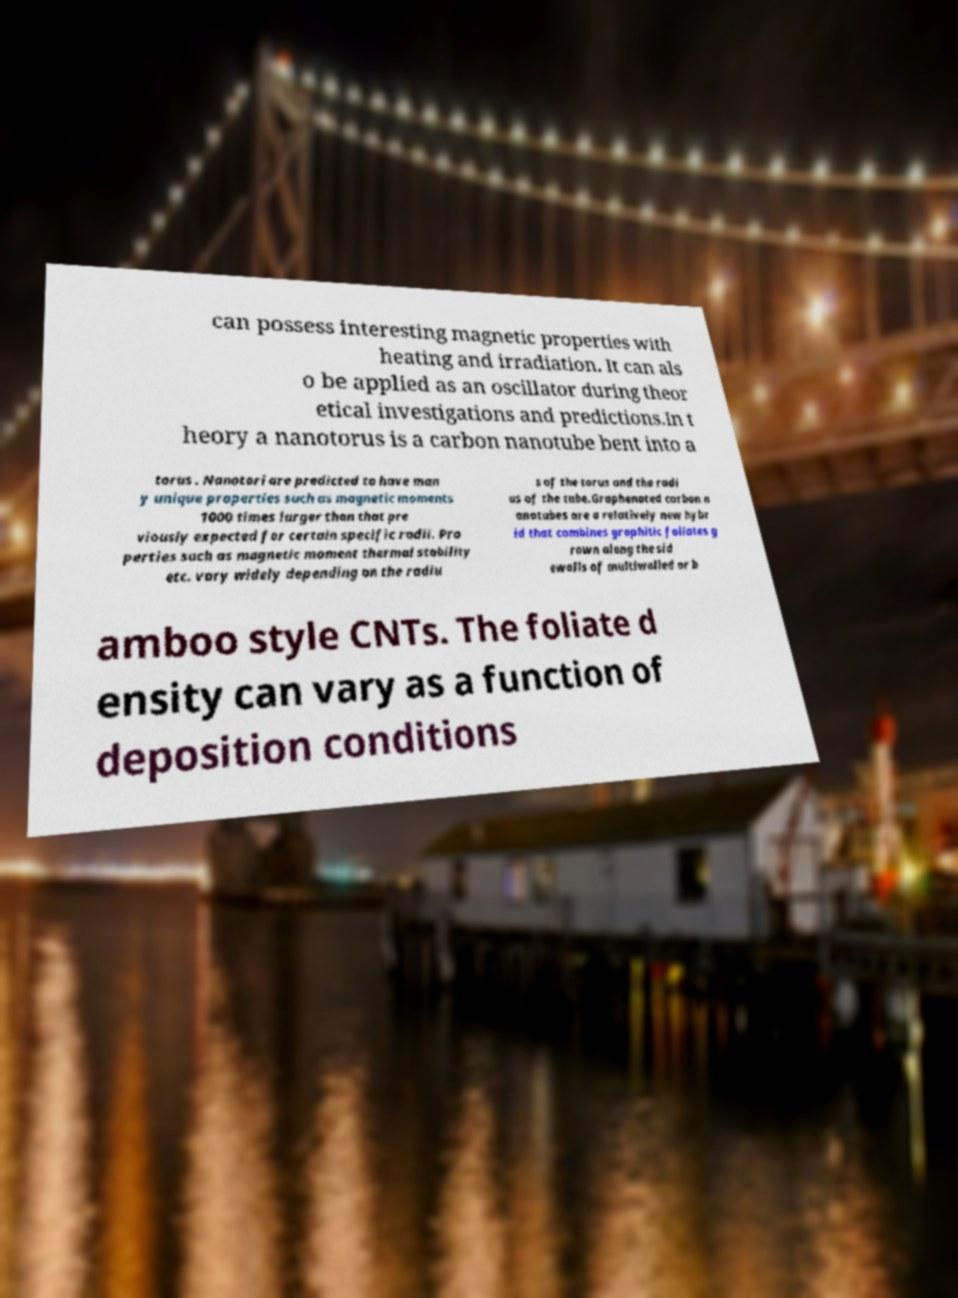What messages or text are displayed in this image? I need them in a readable, typed format. can possess interesting magnetic properties with heating and irradiation. It can als o be applied as an oscillator during theor etical investigations and predictions.In t heory a nanotorus is a carbon nanotube bent into a torus . Nanotori are predicted to have man y unique properties such as magnetic moments 1000 times larger than that pre viously expected for certain specific radii. Pro perties such as magnetic moment thermal stability etc. vary widely depending on the radiu s of the torus and the radi us of the tube.Graphenated carbon n anotubes are a relatively new hybr id that combines graphitic foliates g rown along the sid ewalls of multiwalled or b amboo style CNTs. The foliate d ensity can vary as a function of deposition conditions 